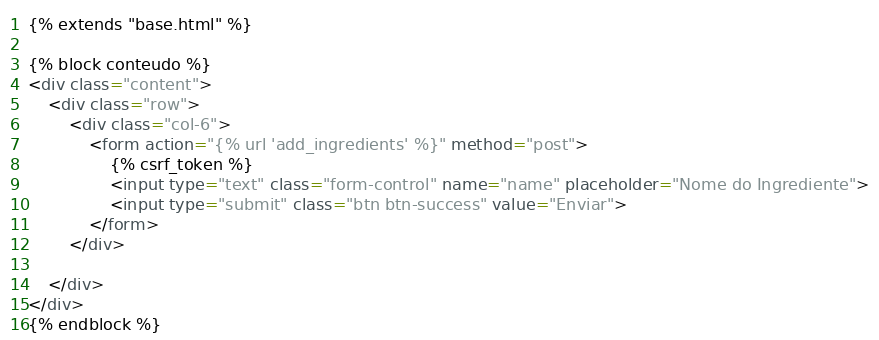Convert code to text. <code><loc_0><loc_0><loc_500><loc_500><_HTML_>
{% extends "base.html" %}

{% block conteudo %}
<div class="content">
	<div class="row">
		<div class="col-6">
			<form action="{% url 'add_ingredients' %}" method="post">
				{% csrf_token %}
				<input type="text" class="form-control" name="name" placeholder="Nome do Ingrediente">
				<input type="submit" class="btn btn-success" value="Enviar">
			</form>
		</div>
		
	</div>
</div>	
{% endblock %}
</code> 